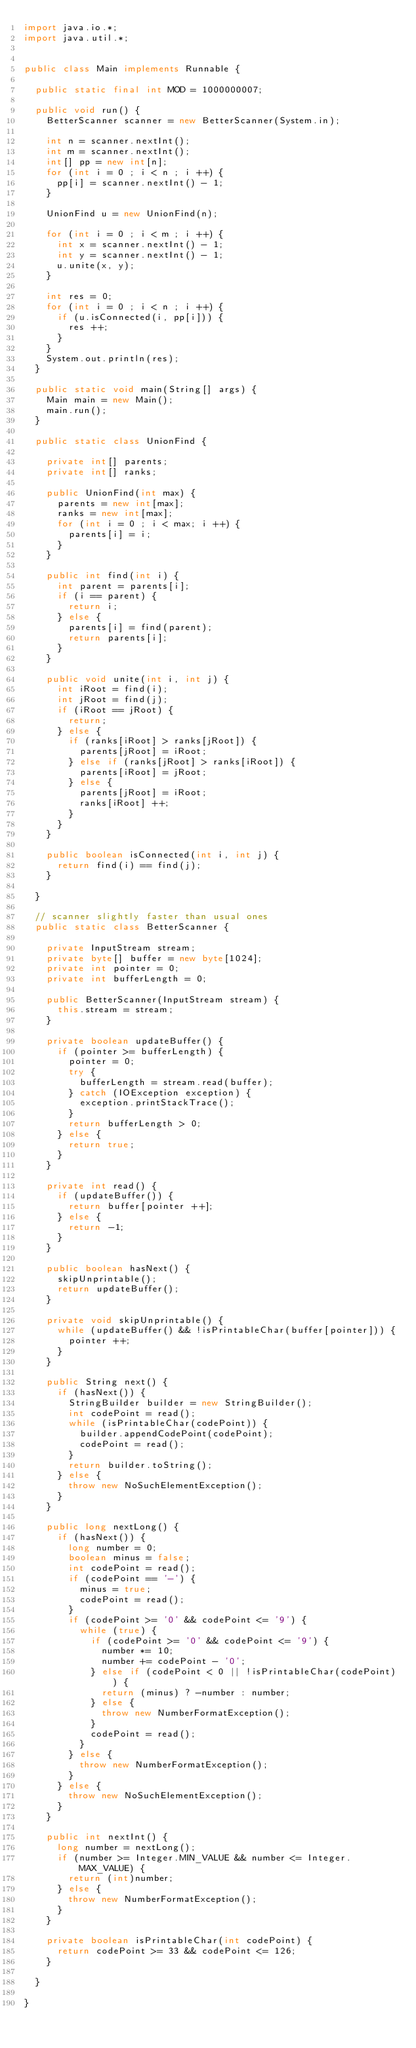Convert code to text. <code><loc_0><loc_0><loc_500><loc_500><_Java_>import java.io.*;
import java.util.*;
 
 
public class Main implements Runnable {
 
  public static final int MOD = 1000000007;

  public void run() {
    BetterScanner scanner = new BetterScanner(System.in);

    int n = scanner.nextInt();
    int m = scanner.nextInt();
    int[] pp = new int[n];
    for (int i = 0 ; i < n ; i ++) {
      pp[i] = scanner.nextInt() - 1;
    }

    UnionFind u = new UnionFind(n);
    
    for (int i = 0 ; i < m ; i ++) {
      int x = scanner.nextInt() - 1;
      int y = scanner.nextInt() - 1;
      u.unite(x, y);
    }

    int res = 0;
    for (int i = 0 ; i < n ; i ++) {
      if (u.isConnected(i, pp[i])) {
        res ++;
      }
    }
    System.out.println(res);
  }

  public static void main(String[] args) {
    Main main = new Main();
    main.run();
  }

  public static class UnionFind {

    private int[] parents;
    private int[] ranks;

    public UnionFind(int max) {
      parents = new int[max];
      ranks = new int[max];
      for (int i = 0 ; i < max; i ++) {
        parents[i] = i;
      }
    }

    public int find(int i) {
      int parent = parents[i];
      if (i == parent) {
        return i;
      } else {
        parents[i] = find(parent);
        return parents[i];
      }
    }

    public void unite(int i, int j) {
      int iRoot = find(i);
      int jRoot = find(j);
      if (iRoot == jRoot) {
        return;
      } else {
        if (ranks[iRoot] > ranks[jRoot]) {
          parents[jRoot] = iRoot;
        } else if (ranks[jRoot] > ranks[iRoot]) {
          parents[iRoot] = jRoot;
        } else {
          parents[jRoot] = iRoot;
          ranks[iRoot] ++;
        }
      }
    }

    public boolean isConnected(int i, int j) {
      return find(i) == find(j);
    }

  }
 
  // scanner slightly faster than usual ones
  public static class BetterScanner {
 
    private InputStream stream;
    private byte[] buffer = new byte[1024];
    private int pointer = 0;
    private int bufferLength = 0;
 
    public BetterScanner(InputStream stream) {
      this.stream = stream;
    }
 
    private boolean updateBuffer() {
      if (pointer >= bufferLength) {
        pointer = 0;
        try {
          bufferLength = stream.read(buffer);
        } catch (IOException exception) {
          exception.printStackTrace();
        }
        return bufferLength > 0;
      } else {
        return true;
      }
    }
 
    private int read() {
      if (updateBuffer()) {
        return buffer[pointer ++];
      } else {
        return -1;
      }
    }
 
    public boolean hasNext() {
      skipUnprintable();
      return updateBuffer();
    }
 
    private void skipUnprintable() { 
      while (updateBuffer() && !isPrintableChar(buffer[pointer])) {
        pointer ++;
      }
    }
 
    public String next() {
      if (hasNext()) {
        StringBuilder builder = new StringBuilder();
        int codePoint = read();
        while (isPrintableChar(codePoint)) {
          builder.appendCodePoint(codePoint);
          codePoint = read();
        }
        return builder.toString();
      } else {
        throw new NoSuchElementException();
      }
    }
 
    public long nextLong() {
      if (hasNext()) {
        long number = 0;
        boolean minus = false;
        int codePoint = read();
        if (codePoint == '-') {
          minus = true;
          codePoint = read();
        }
        if (codePoint >= '0' && codePoint <= '9') {
          while (true) {
            if (codePoint >= '0' && codePoint <= '9') {
              number *= 10;
              number += codePoint - '0';
            } else if (codePoint < 0 || !isPrintableChar(codePoint)) {
              return (minus) ? -number : number;
            } else {
              throw new NumberFormatException();
            }
            codePoint = read();
          }
        } else {
          throw new NumberFormatException();
        }
      } else {
        throw new NoSuchElementException();
      }
    }
 
    public int nextInt() {
      long number = nextLong();
      if (number >= Integer.MIN_VALUE && number <= Integer.MAX_VALUE) {
        return (int)number;
      } else {
        throw new NumberFormatException();
      }
    }
 
    private boolean isPrintableChar(int codePoint) {
      return codePoint >= 33 && codePoint <= 126;
    }
 
  }
 
}
</code> 